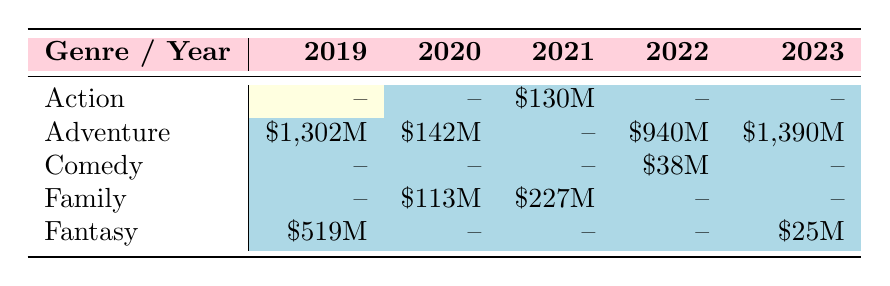What is the highest box office earning for an animated film in 2022? The table shows that "Minions: The Rise of Gru" earned \$940 million in 2022, which is the only entry under Adventure for that year and is also the highest figure for that year's entries.
Answer: 940M How much did "Soul" earn at the box office in 2020? The table lists "Soul" under Family for the year 2020 with a box office earning of \$113 million.
Answer: 113M Which genre had the highest box office earnings in 2019? The table shows that Adventure had the highest earnings of \$1,302 million in 2019 with "Frozen II." Comparatively, Fantasy earned \$519 million, which is lower.
Answer: Adventure Is there any animated film that earned over \$1 billion at the box office in 2023? The table displays "The Super Mario Bros. Movie" earning \$1,390 million in 2023. Thus, there is one film that has crossed over \$1 billion in that year.
Answer: Yes What is the total box office earning for the Adventure genre across all years in the table? The earnings for Adventure are as follows: 2019: \$1,302 million, 2020: \$142 million, 2022: \$940 million, 2023: \$1,390 million. Adding these amounts gives \$1,302M + \$142M + \$940M + \$1,390M = \$3,774 million.
Answer: 3774M How many films in total are represented in the table for the Family genre? The table lists two films under the Family genre: "Soul" in 2020 and "Luca" in 2021, making the total count two.
Answer: 2 Did any film released in 2021 earn more than \$200 million? According to the table, "Luca" earned \$227 million, which is greater than \$200 million, while "Raya and the Last Dragon" earned \$130 million. Thus, one film qualifies.
Answer: Yes Which film represented the Comedy genre, and what was its box office earning? The table shows "The Bob's Burgers Movie" as the only film in the Comedy genre that earned \$38 million.
Answer: The Bob's Burgers Movie, 38M What is the box office difference between the highest and lowest earning films in 2022? In 2022, "Minions: The Rise of Gru" earned \$940 million while "The Bob's Burgers Movie" earned \$38 million. The difference is \$940M - \$38M = \$902 million.
Answer: 902M 